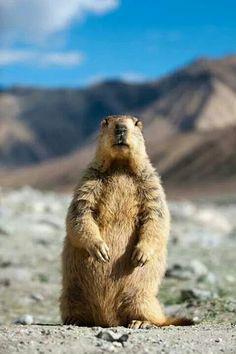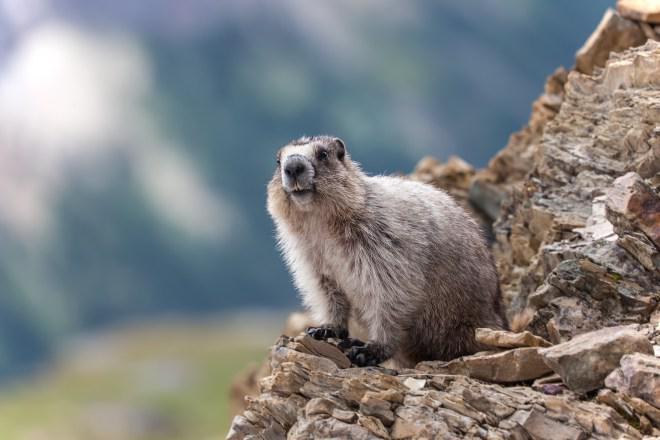The first image is the image on the left, the second image is the image on the right. Evaluate the accuracy of this statement regarding the images: "In one of the images there is an animal facing right.". Is it true? Answer yes or no. No. 